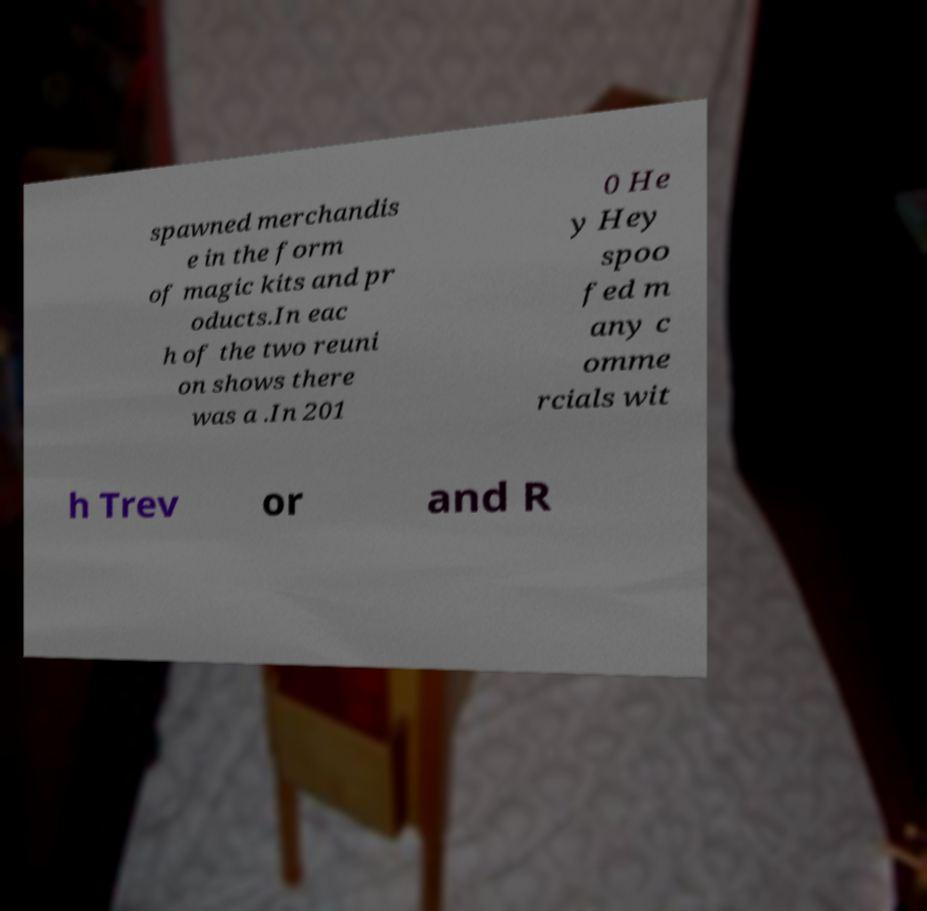Please identify and transcribe the text found in this image. spawned merchandis e in the form of magic kits and pr oducts.In eac h of the two reuni on shows there was a .In 201 0 He y Hey spoo fed m any c omme rcials wit h Trev or and R 